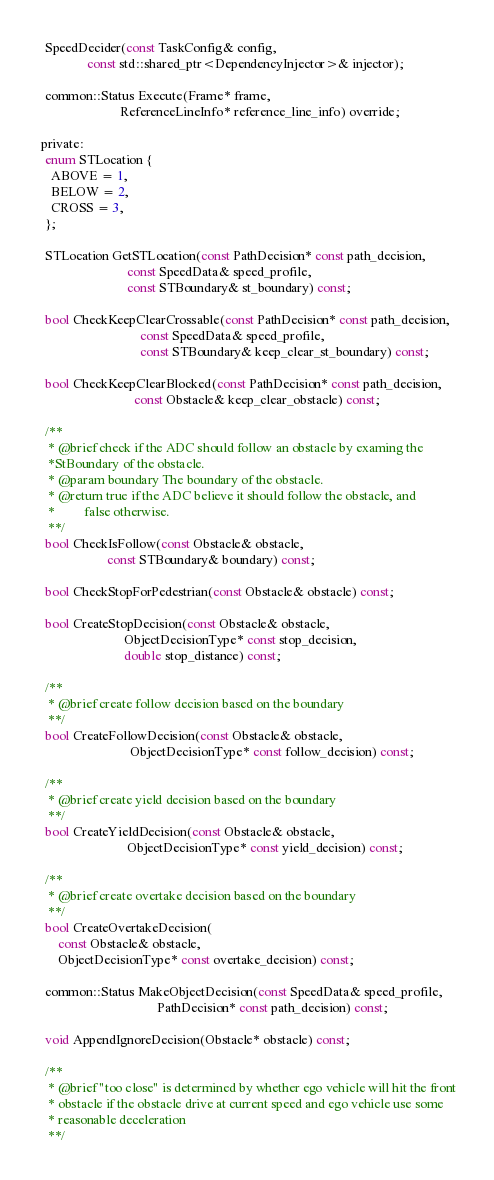Convert code to text. <code><loc_0><loc_0><loc_500><loc_500><_C_>  SpeedDecider(const TaskConfig& config,
               const std::shared_ptr<DependencyInjector>& injector);

  common::Status Execute(Frame* frame,
                         ReferenceLineInfo* reference_line_info) override;

 private:
  enum STLocation {
    ABOVE = 1,
    BELOW = 2,
    CROSS = 3,
  };

  STLocation GetSTLocation(const PathDecision* const path_decision,
                           const SpeedData& speed_profile,
                           const STBoundary& st_boundary) const;

  bool CheckKeepClearCrossable(const PathDecision* const path_decision,
                               const SpeedData& speed_profile,
                               const STBoundary& keep_clear_st_boundary) const;

  bool CheckKeepClearBlocked(const PathDecision* const path_decision,
                             const Obstacle& keep_clear_obstacle) const;

  /**
   * @brief check if the ADC should follow an obstacle by examing the
   *StBoundary of the obstacle.
   * @param boundary The boundary of the obstacle.
   * @return true if the ADC believe it should follow the obstacle, and
   *         false otherwise.
   **/
  bool CheckIsFollow(const Obstacle& obstacle,
                     const STBoundary& boundary) const;

  bool CheckStopForPedestrian(const Obstacle& obstacle) const;

  bool CreateStopDecision(const Obstacle& obstacle,
                          ObjectDecisionType* const stop_decision,
                          double stop_distance) const;

  /**
   * @brief create follow decision based on the boundary
   **/
  bool CreateFollowDecision(const Obstacle& obstacle,
                            ObjectDecisionType* const follow_decision) const;

  /**
   * @brief create yield decision based on the boundary
   **/
  bool CreateYieldDecision(const Obstacle& obstacle,
                           ObjectDecisionType* const yield_decision) const;

  /**
   * @brief create overtake decision based on the boundary
   **/
  bool CreateOvertakeDecision(
      const Obstacle& obstacle,
      ObjectDecisionType* const overtake_decision) const;

  common::Status MakeObjectDecision(const SpeedData& speed_profile,
                                    PathDecision* const path_decision) const;

  void AppendIgnoreDecision(Obstacle* obstacle) const;

  /**
   * @brief "too close" is determined by whether ego vehicle will hit the front
   * obstacle if the obstacle drive at current speed and ego vehicle use some
   * reasonable deceleration
   **/</code> 